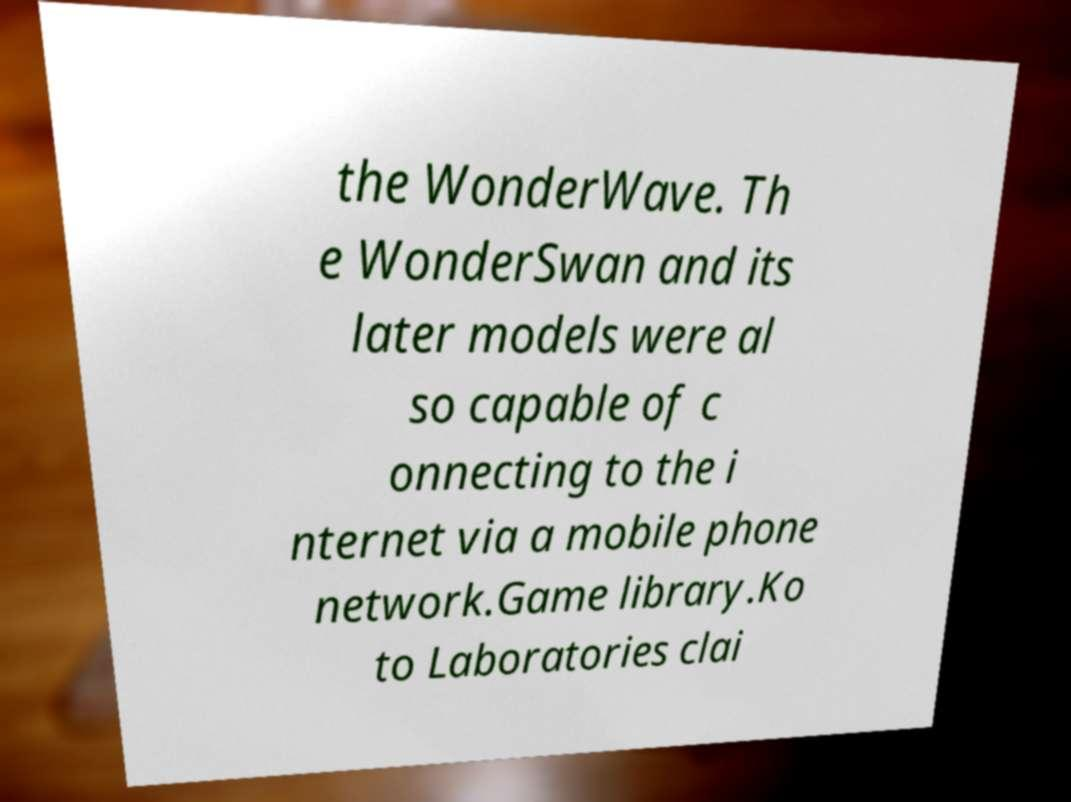Could you extract and type out the text from this image? the WonderWave. Th e WonderSwan and its later models were al so capable of c onnecting to the i nternet via a mobile phone network.Game library.Ko to Laboratories clai 